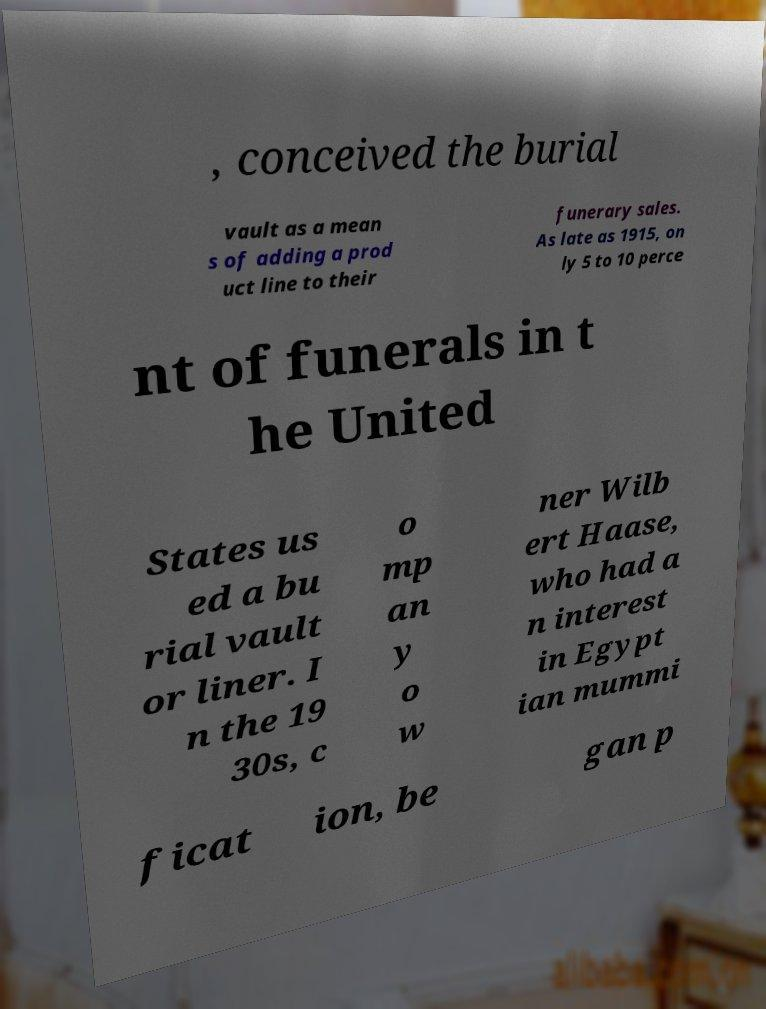I need the written content from this picture converted into text. Can you do that? , conceived the burial vault as a mean s of adding a prod uct line to their funerary sales. As late as 1915, on ly 5 to 10 perce nt of funerals in t he United States us ed a bu rial vault or liner. I n the 19 30s, c o mp an y o w ner Wilb ert Haase, who had a n interest in Egypt ian mummi ficat ion, be gan p 